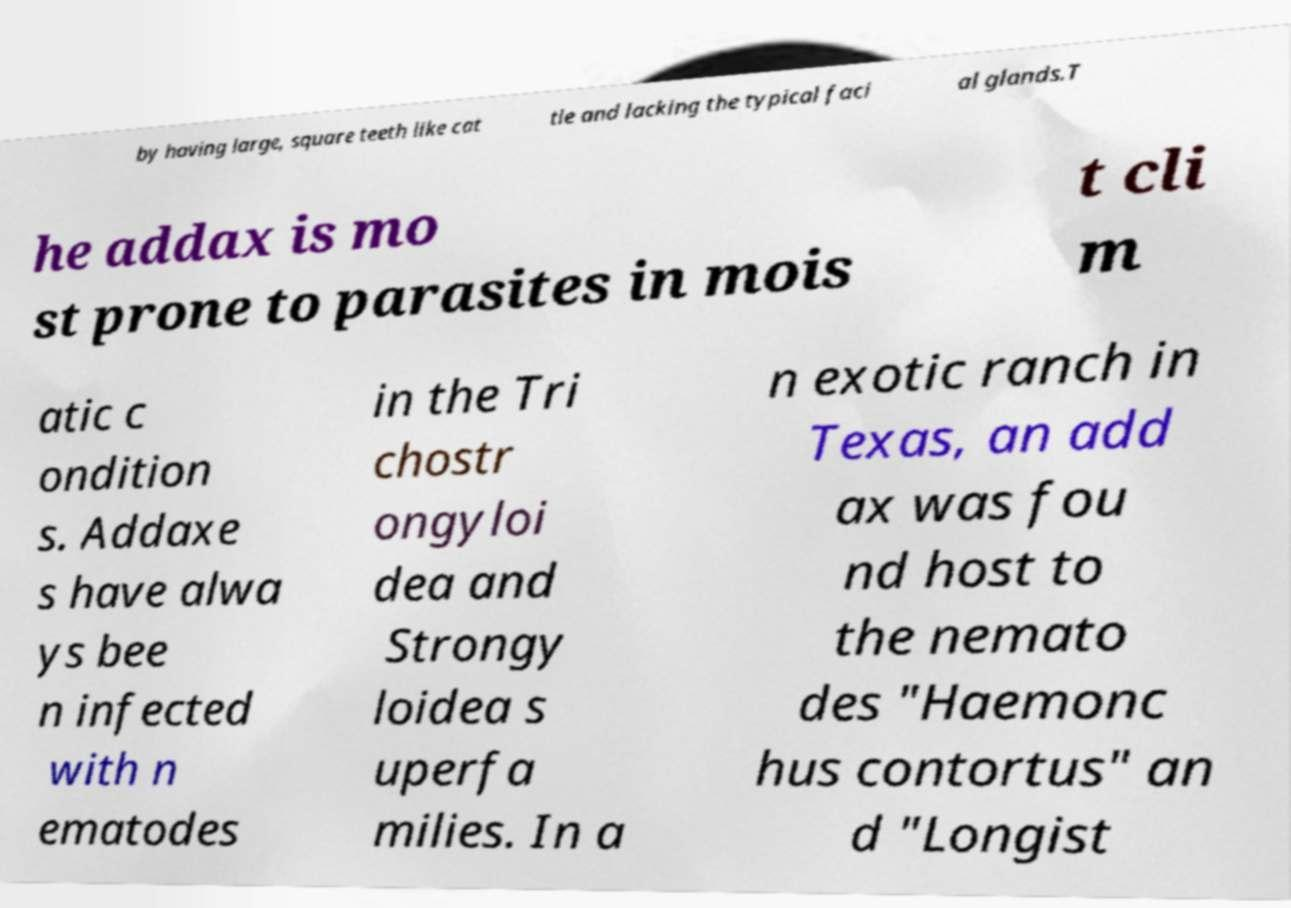Can you accurately transcribe the text from the provided image for me? by having large, square teeth like cat tle and lacking the typical faci al glands.T he addax is mo st prone to parasites in mois t cli m atic c ondition s. Addaxe s have alwa ys bee n infected with n ematodes in the Tri chostr ongyloi dea and Strongy loidea s uperfa milies. In a n exotic ranch in Texas, an add ax was fou nd host to the nemato des "Haemonc hus contortus" an d "Longist 